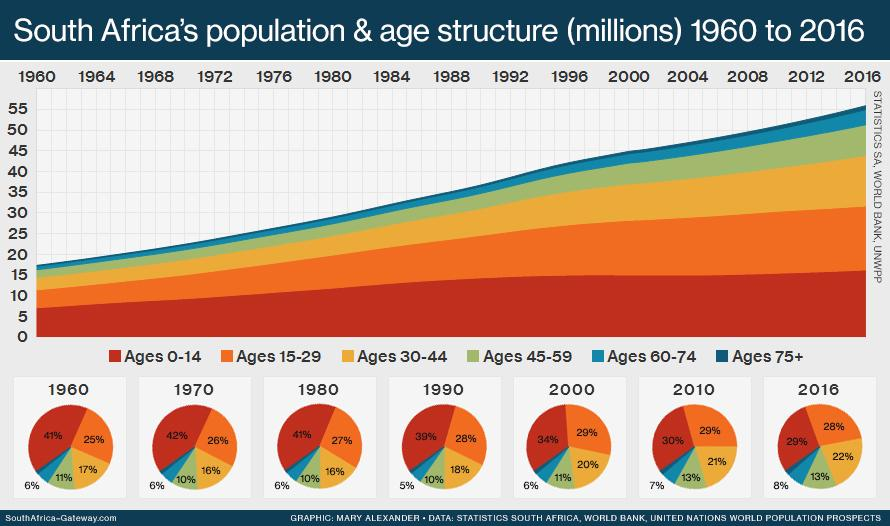Highlight a few significant elements in this photo. The age group represented by the color yellow is 30-44 years old. For over seven decades, the population has shown a continuous decline in the ages 0-14 age group. In 1980, the age group with the highest population was ages 0-14. In 1970, approximately 26% of the population belonged to the age group 15-29. In 1990, approximately 10% of the population belonged to the age group 45-59. 